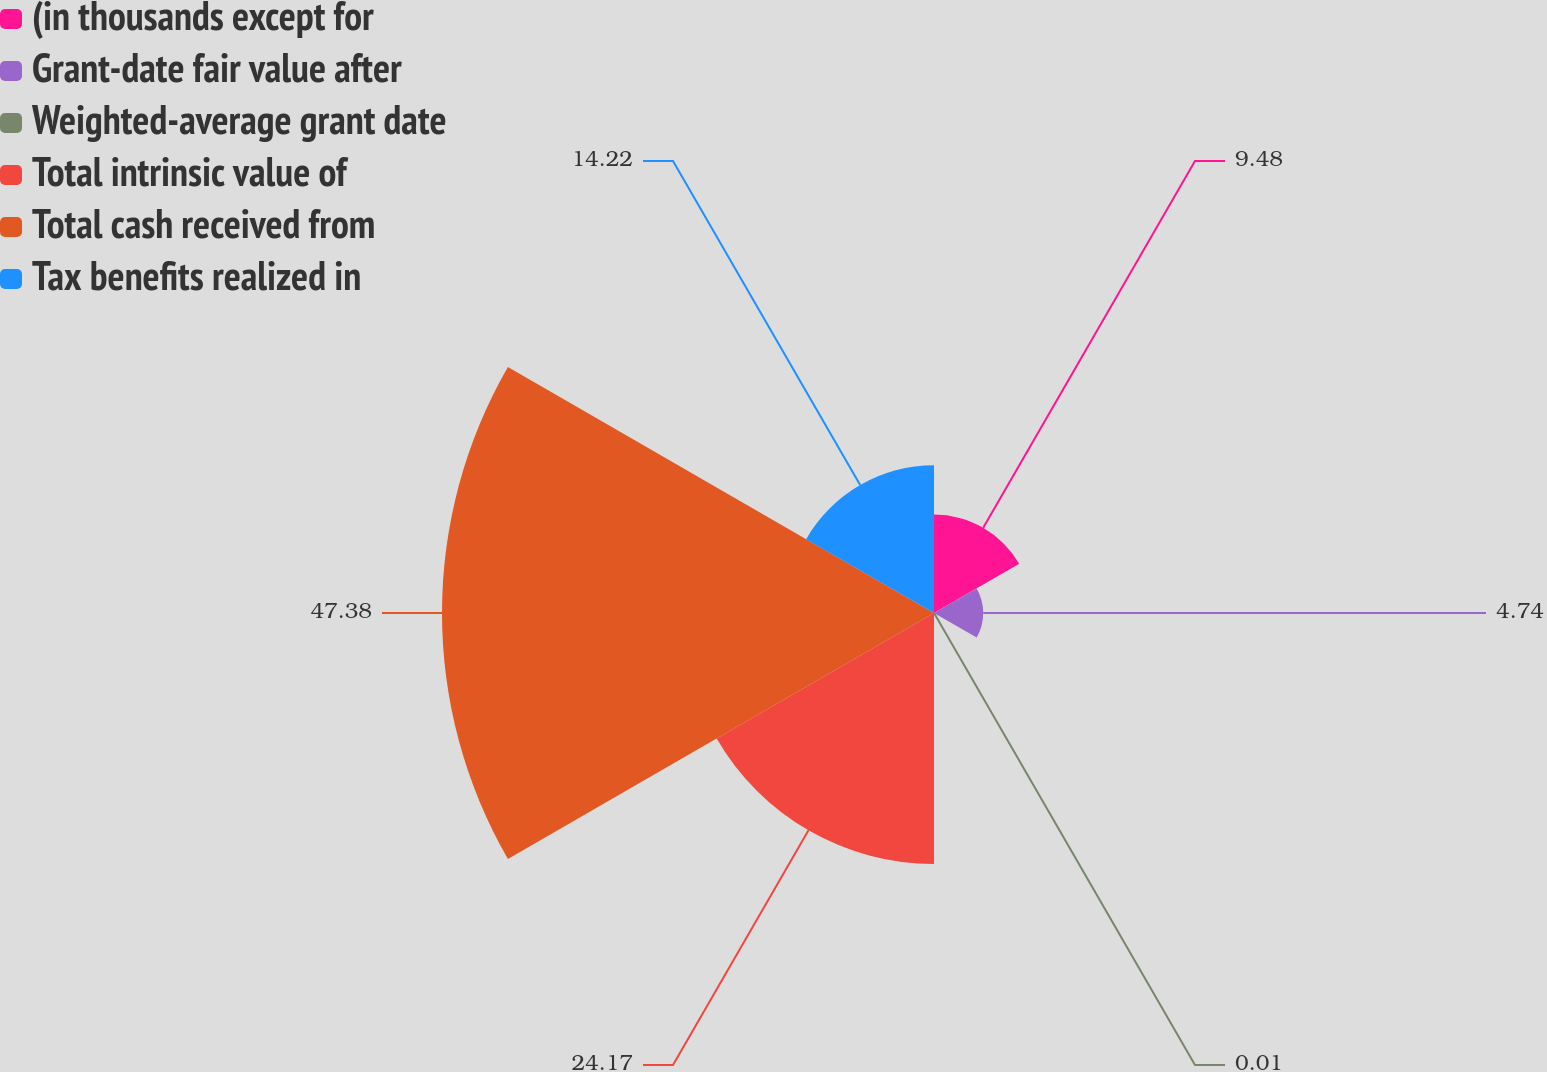<chart> <loc_0><loc_0><loc_500><loc_500><pie_chart><fcel>(in thousands except for<fcel>Grant-date fair value after<fcel>Weighted-average grant date<fcel>Total intrinsic value of<fcel>Total cash received from<fcel>Tax benefits realized in<nl><fcel>9.48%<fcel>4.74%<fcel>0.01%<fcel>24.17%<fcel>47.38%<fcel>14.22%<nl></chart> 